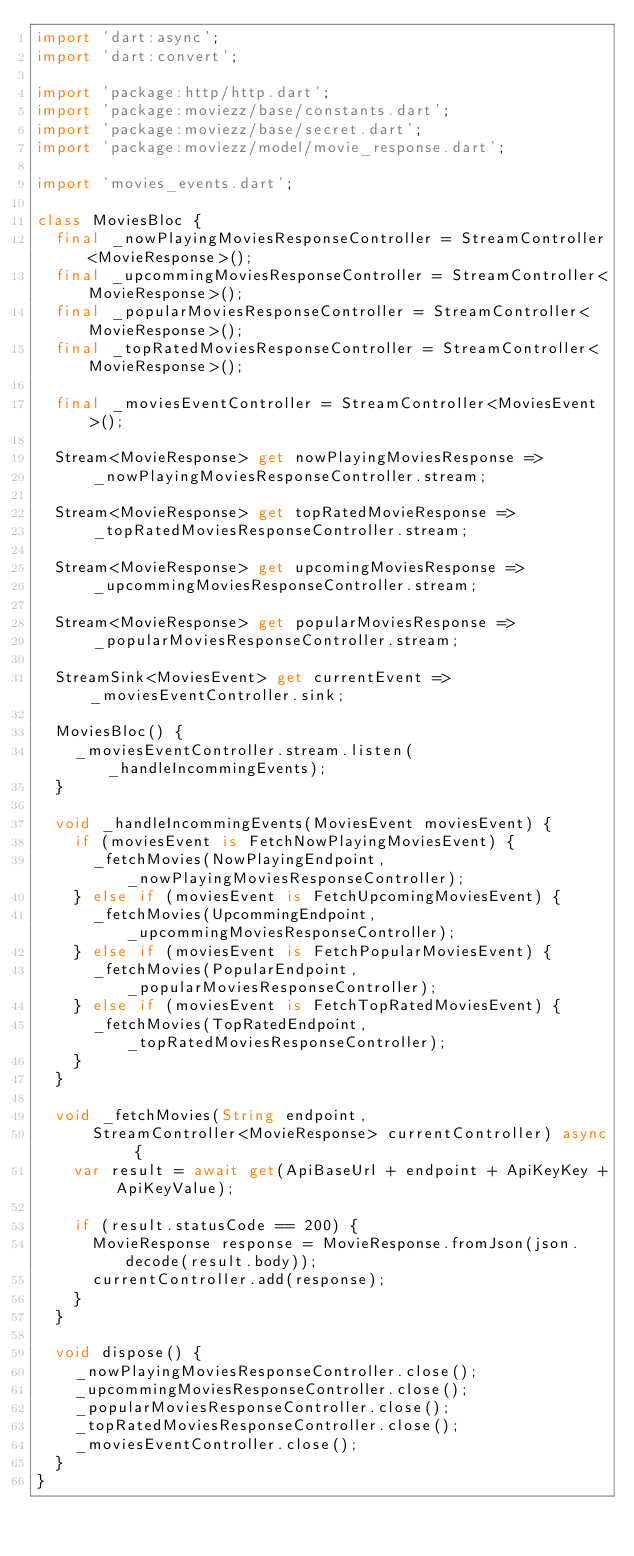<code> <loc_0><loc_0><loc_500><loc_500><_Dart_>import 'dart:async';
import 'dart:convert';

import 'package:http/http.dart';
import 'package:moviezz/base/constants.dart';
import 'package:moviezz/base/secret.dart';
import 'package:moviezz/model/movie_response.dart';

import 'movies_events.dart';

class MoviesBloc {
  final _nowPlayingMoviesResponseController = StreamController<MovieResponse>();
  final _upcommingMoviesResponseController = StreamController<MovieResponse>();
  final _popularMoviesResponseController = StreamController<MovieResponse>();
  final _topRatedMoviesResponseController = StreamController<MovieResponse>();

  final _moviesEventController = StreamController<MoviesEvent>();

  Stream<MovieResponse> get nowPlayingMoviesResponse =>
      _nowPlayingMoviesResponseController.stream;

  Stream<MovieResponse> get topRatedMovieResponse =>
      _topRatedMoviesResponseController.stream;

  Stream<MovieResponse> get upcomingMoviesResponse =>
      _upcommingMoviesResponseController.stream;

  Stream<MovieResponse> get popularMoviesResponse =>
      _popularMoviesResponseController.stream;

  StreamSink<MoviesEvent> get currentEvent => _moviesEventController.sink;

  MoviesBloc() {
    _moviesEventController.stream.listen(_handleIncommingEvents);
  }

  void _handleIncommingEvents(MoviesEvent moviesEvent) {
    if (moviesEvent is FetchNowPlayingMoviesEvent) {
      _fetchMovies(NowPlayingEndpoint, _nowPlayingMoviesResponseController);
    } else if (moviesEvent is FetchUpcomingMoviesEvent) {
      _fetchMovies(UpcommingEndpoint, _upcommingMoviesResponseController);
    } else if (moviesEvent is FetchPopularMoviesEvent) {
      _fetchMovies(PopularEndpoint, _popularMoviesResponseController);
    } else if (moviesEvent is FetchTopRatedMoviesEvent) {
      _fetchMovies(TopRatedEndpoint, _topRatedMoviesResponseController);
    }
  }

  void _fetchMovies(String endpoint,
      StreamController<MovieResponse> currentController) async {
    var result = await get(ApiBaseUrl + endpoint + ApiKeyKey + ApiKeyValue);

    if (result.statusCode == 200) {
      MovieResponse response = MovieResponse.fromJson(json.decode(result.body));
      currentController.add(response);
    }
  }

  void dispose() {
    _nowPlayingMoviesResponseController.close();
    _upcommingMoviesResponseController.close();
    _popularMoviesResponseController.close();
    _topRatedMoviesResponseController.close();
    _moviesEventController.close();
  }
}
</code> 